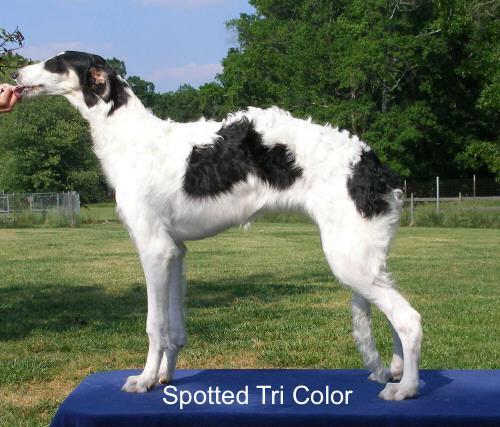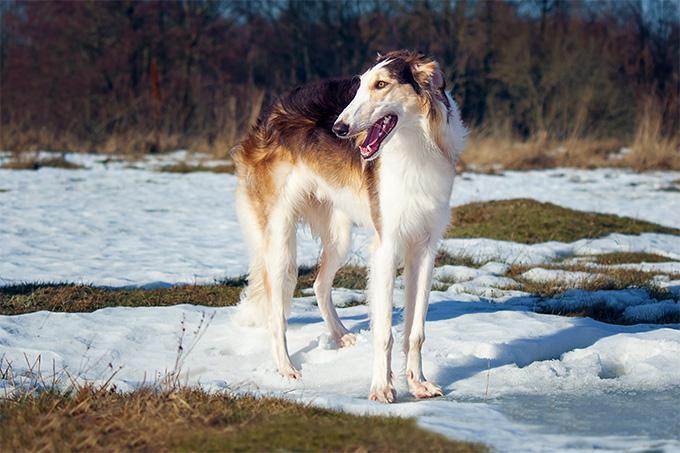The first image is the image on the left, the second image is the image on the right. Examine the images to the left and right. Is the description "There are two do" accurate? Answer yes or no. Yes. The first image is the image on the left, the second image is the image on the right. Analyze the images presented: Is the assertion "One image shows two hounds with similar coloration." valid? Answer yes or no. No. 